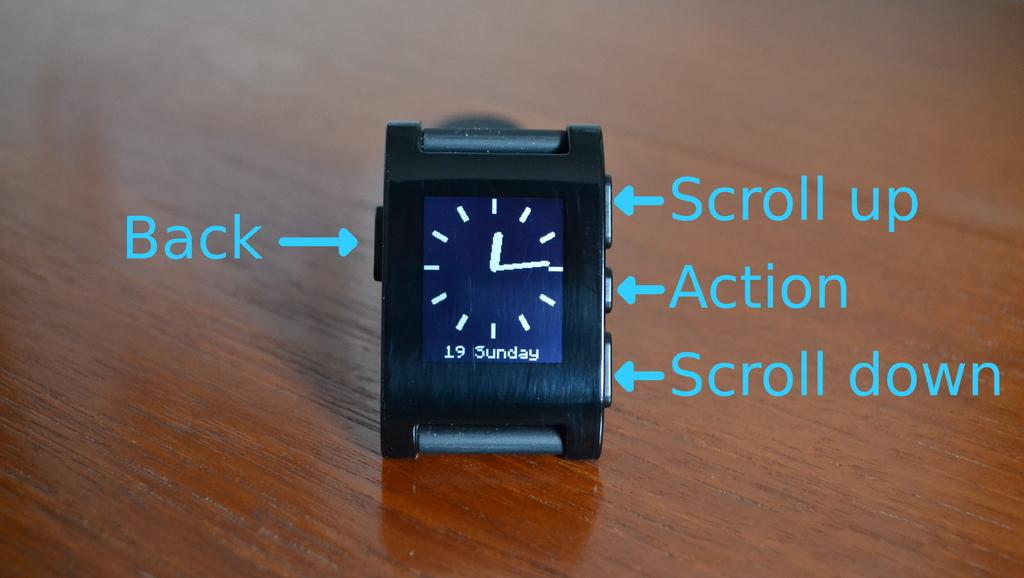What date is on the watch?
Your answer should be compact. 19 sunday. What time does the watch display?
Provide a short and direct response. 12:14. 